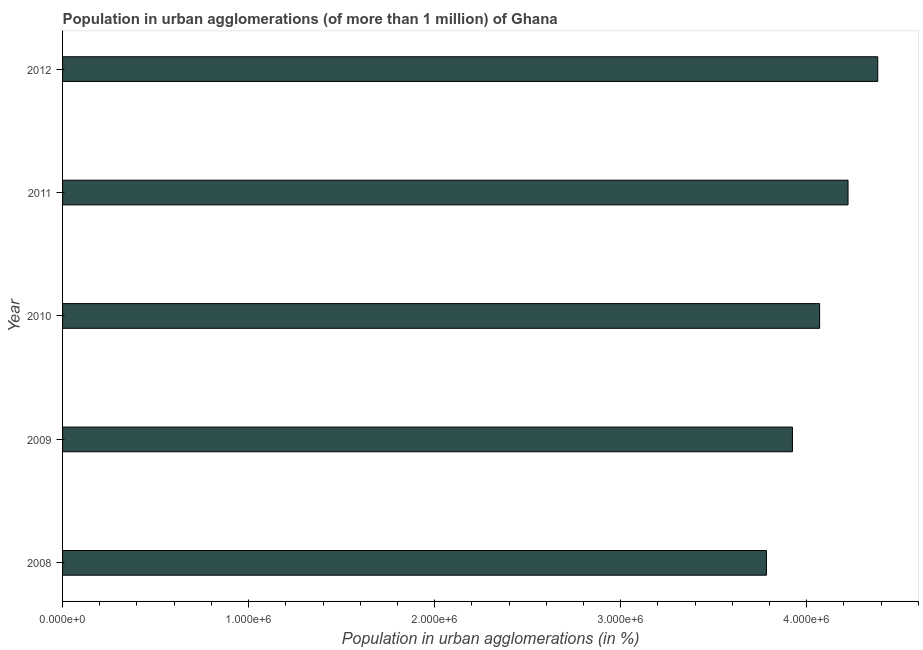Does the graph contain grids?
Offer a terse response. No. What is the title of the graph?
Offer a very short reply. Population in urban agglomerations (of more than 1 million) of Ghana. What is the label or title of the X-axis?
Keep it short and to the point. Population in urban agglomerations (in %). What is the label or title of the Y-axis?
Give a very brief answer. Year. What is the population in urban agglomerations in 2011?
Your response must be concise. 4.22e+06. Across all years, what is the maximum population in urban agglomerations?
Offer a very short reply. 4.38e+06. Across all years, what is the minimum population in urban agglomerations?
Make the answer very short. 3.78e+06. What is the sum of the population in urban agglomerations?
Keep it short and to the point. 2.04e+07. What is the difference between the population in urban agglomerations in 2010 and 2011?
Your response must be concise. -1.53e+05. What is the average population in urban agglomerations per year?
Keep it short and to the point. 4.08e+06. What is the median population in urban agglomerations?
Keep it short and to the point. 4.07e+06. What is the ratio of the population in urban agglomerations in 2009 to that in 2011?
Keep it short and to the point. 0.93. Is the population in urban agglomerations in 2008 less than that in 2009?
Ensure brevity in your answer.  Yes. What is the difference between the highest and the second highest population in urban agglomerations?
Your response must be concise. 1.60e+05. Is the sum of the population in urban agglomerations in 2008 and 2011 greater than the maximum population in urban agglomerations across all years?
Provide a short and direct response. Yes. What is the difference between the highest and the lowest population in urban agglomerations?
Keep it short and to the point. 5.98e+05. In how many years, is the population in urban agglomerations greater than the average population in urban agglomerations taken over all years?
Provide a succinct answer. 2. How many years are there in the graph?
Provide a succinct answer. 5. What is the Population in urban agglomerations (in %) in 2008?
Give a very brief answer. 3.78e+06. What is the Population in urban agglomerations (in %) in 2009?
Offer a very short reply. 3.92e+06. What is the Population in urban agglomerations (in %) in 2010?
Provide a succinct answer. 4.07e+06. What is the Population in urban agglomerations (in %) of 2011?
Make the answer very short. 4.22e+06. What is the Population in urban agglomerations (in %) in 2012?
Make the answer very short. 4.38e+06. What is the difference between the Population in urban agglomerations (in %) in 2008 and 2009?
Ensure brevity in your answer.  -1.40e+05. What is the difference between the Population in urban agglomerations (in %) in 2008 and 2010?
Your answer should be very brief. -2.86e+05. What is the difference between the Population in urban agglomerations (in %) in 2008 and 2011?
Provide a short and direct response. -4.39e+05. What is the difference between the Population in urban agglomerations (in %) in 2008 and 2012?
Keep it short and to the point. -5.98e+05. What is the difference between the Population in urban agglomerations (in %) in 2009 and 2010?
Your answer should be compact. -1.46e+05. What is the difference between the Population in urban agglomerations (in %) in 2009 and 2011?
Your answer should be compact. -2.99e+05. What is the difference between the Population in urban agglomerations (in %) in 2009 and 2012?
Give a very brief answer. -4.58e+05. What is the difference between the Population in urban agglomerations (in %) in 2010 and 2011?
Offer a very short reply. -1.53e+05. What is the difference between the Population in urban agglomerations (in %) in 2010 and 2012?
Give a very brief answer. -3.12e+05. What is the difference between the Population in urban agglomerations (in %) in 2011 and 2012?
Your answer should be very brief. -1.60e+05. What is the ratio of the Population in urban agglomerations (in %) in 2008 to that in 2010?
Your response must be concise. 0.93. What is the ratio of the Population in urban agglomerations (in %) in 2008 to that in 2011?
Offer a terse response. 0.9. What is the ratio of the Population in urban agglomerations (in %) in 2008 to that in 2012?
Your answer should be very brief. 0.86. What is the ratio of the Population in urban agglomerations (in %) in 2009 to that in 2010?
Offer a terse response. 0.96. What is the ratio of the Population in urban agglomerations (in %) in 2009 to that in 2011?
Provide a succinct answer. 0.93. What is the ratio of the Population in urban agglomerations (in %) in 2009 to that in 2012?
Provide a short and direct response. 0.9. What is the ratio of the Population in urban agglomerations (in %) in 2010 to that in 2011?
Make the answer very short. 0.96. What is the ratio of the Population in urban agglomerations (in %) in 2010 to that in 2012?
Ensure brevity in your answer.  0.93. What is the ratio of the Population in urban agglomerations (in %) in 2011 to that in 2012?
Give a very brief answer. 0.96. 